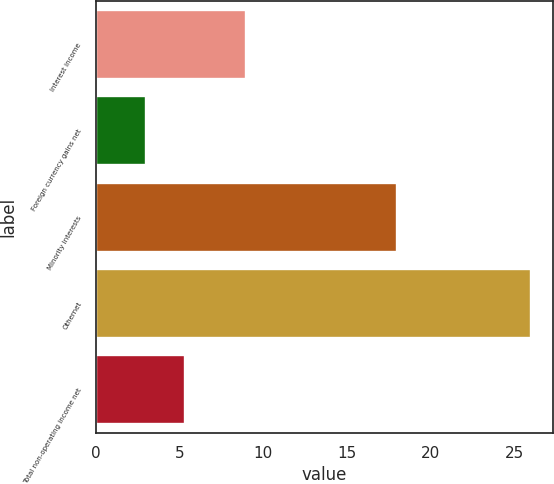<chart> <loc_0><loc_0><loc_500><loc_500><bar_chart><fcel>Interest income<fcel>Foreign currency gains net<fcel>Minority interests<fcel>Othernet<fcel>Total non-operating income net<nl><fcel>9<fcel>3<fcel>18<fcel>26<fcel>5.3<nl></chart> 